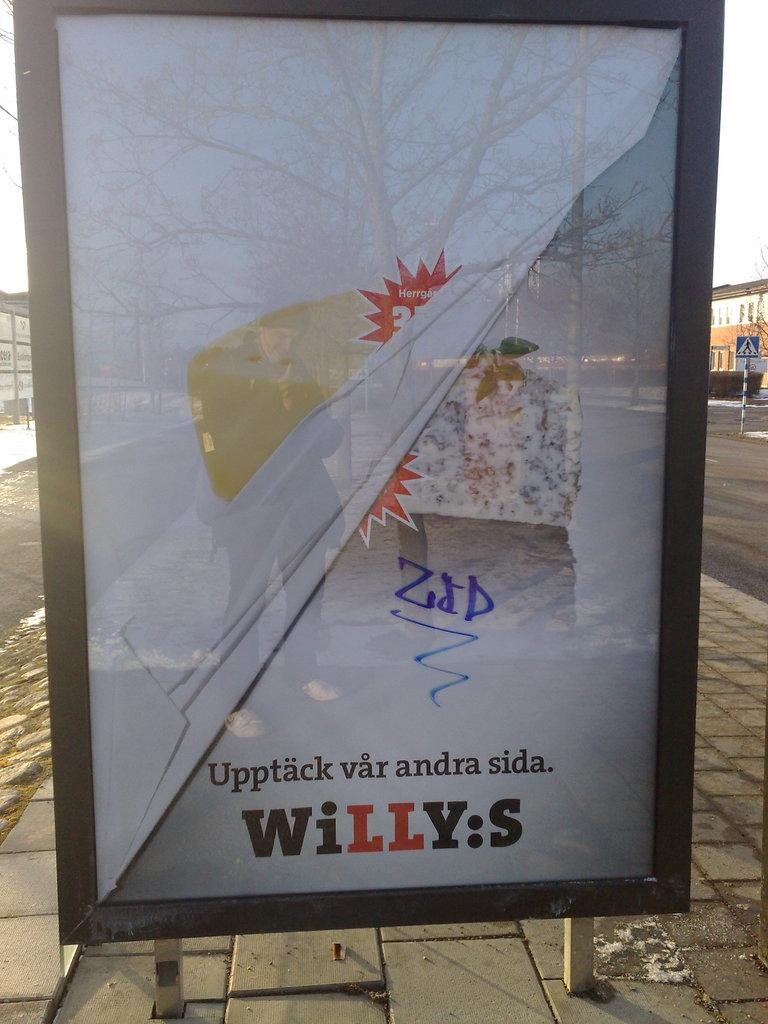<image>
Present a compact description of the photo's key features. a glass incased sign for willy:s on the sidewalk 